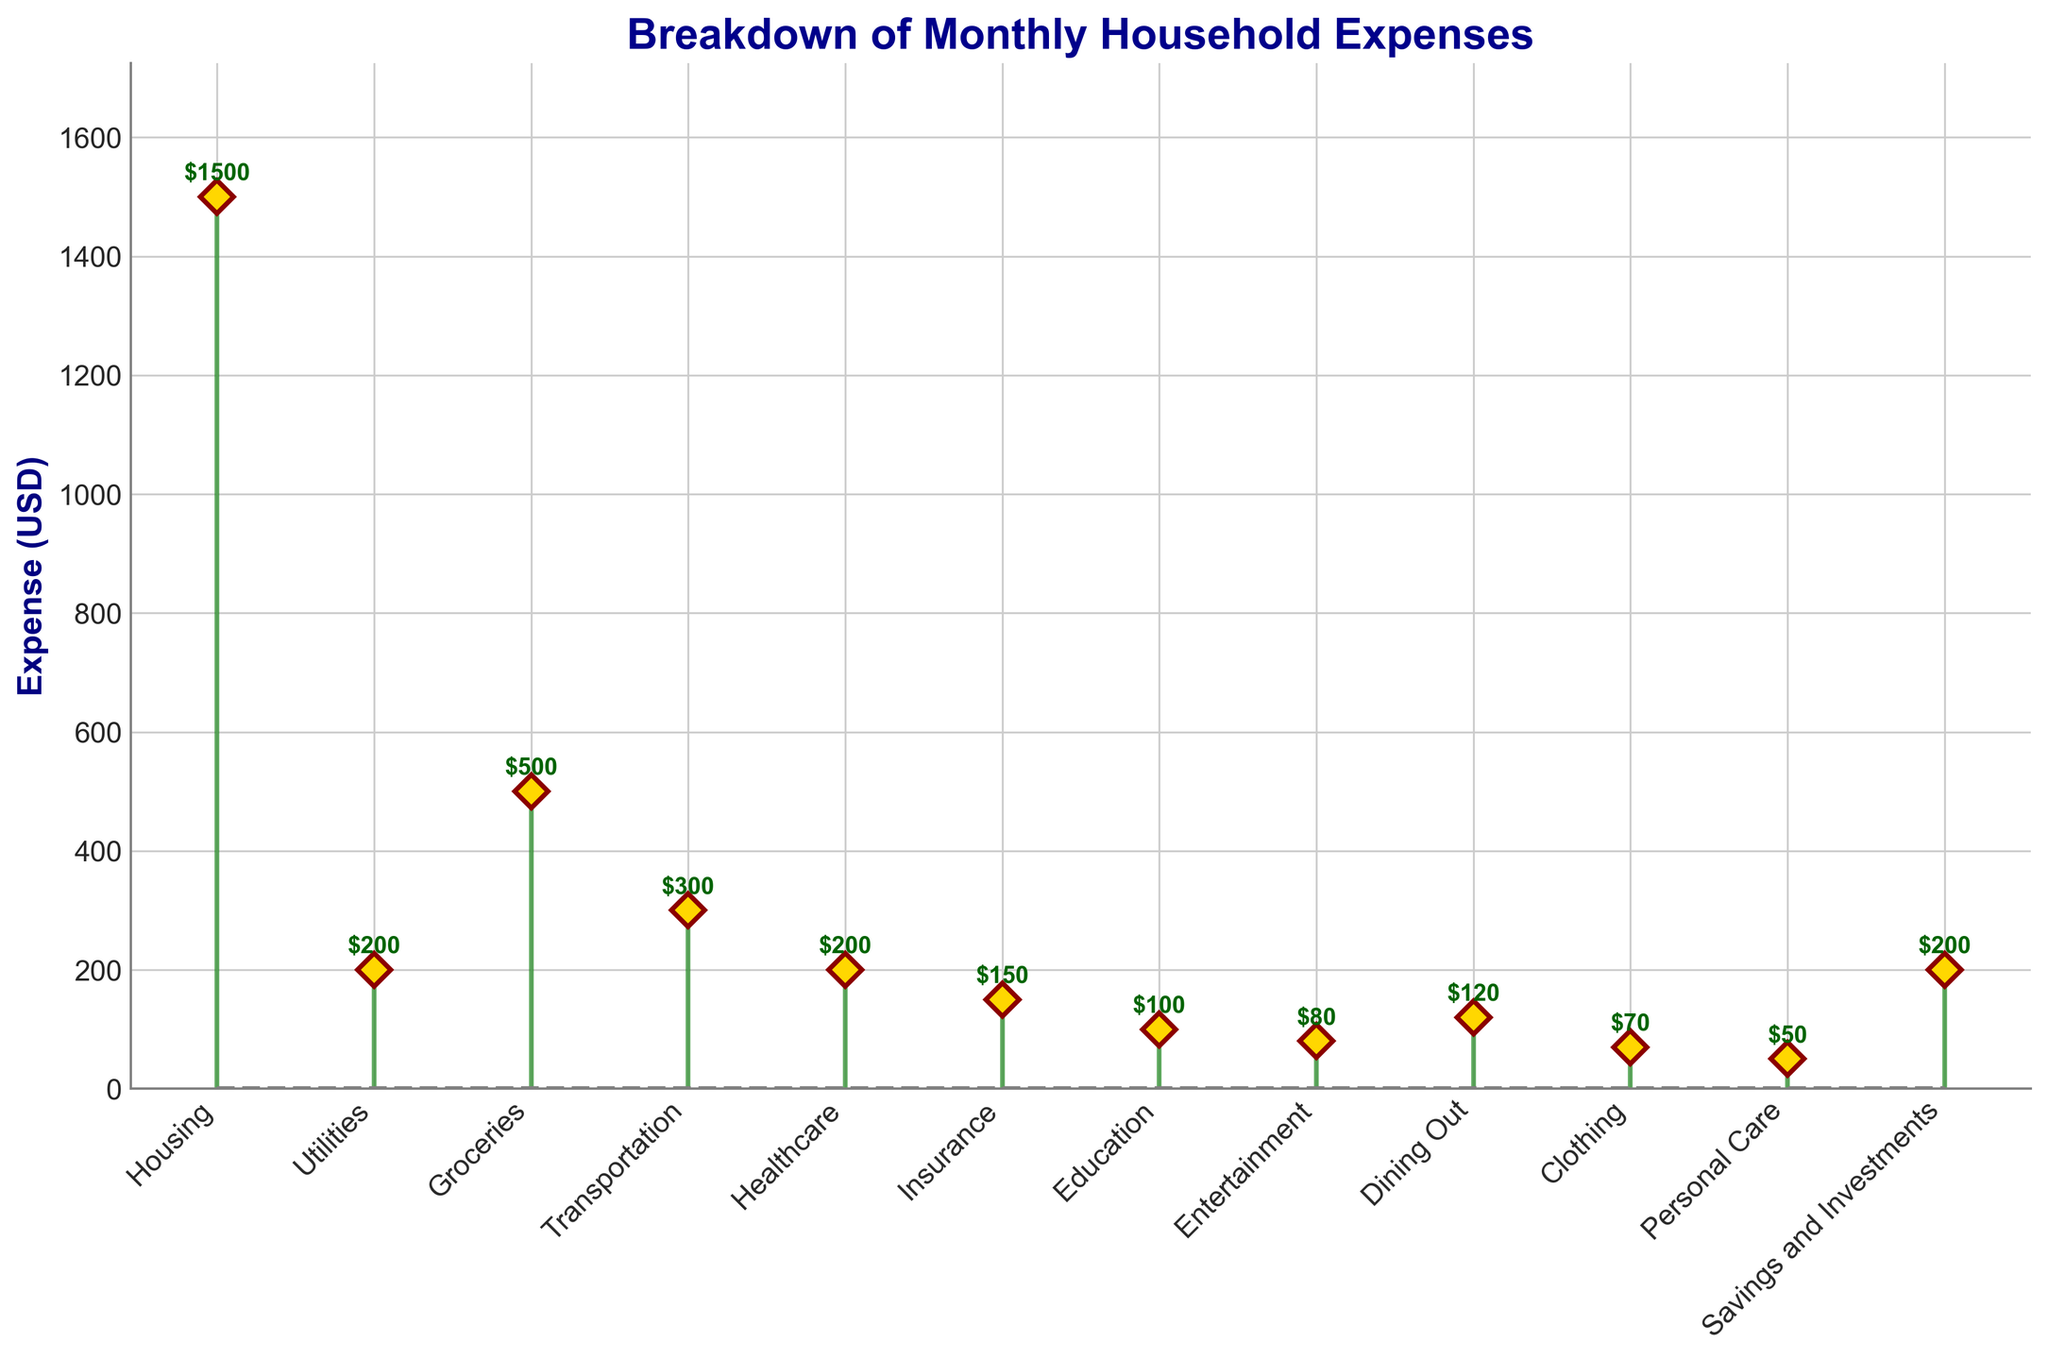What is the title of the plot? The title is usually found at the top of the plot, written in a larger font and often in bold. In this case, it is clear and easy to read.
Answer: Breakdown of Monthly Household Expenses What is the expense for Housing? Look for the "Housing" category on the x-axis and check the value explicitly labeled next to it.
Answer: $1500 How many categories have an expense of $200 or less? Identify and count the bars or markers with values of $200, $150, $100, $80, $70, and $50 accordingly. Here, those categories are Utilities, Healthcare, Insurance, Education, Entertainment, Clothing, and Personal Care.
Answer: 7 Which category has the lowest expense? Examine all the expenses noted on the markers to find the smallest value, which corresponds to the smallest label.
Answer: Personal Care How much more do Housing expenses exceed Groceries expenses? Find the amounts for Housing ($1500) and Groceries ($500). Subtract the Groceries expense from the Housing expense: $1500 - $500 = $1000.
Answer: $1000 What is the total expense for necessities (Housing, Utilities, Groceries, and Transportation)? Add the expenses of these categories: $1500 (Housing) + $200 (Utilities) + $500 (Groceries) + $300 (Transportation) = $2500.
Answer: $2500 Which two categories combined make up an expense equal to Healthcare? Look for two categories whose sum is $200. In this case, $150 (Insurance) + $50 (Personal Care) = $200.
Answer: Insurance and Personal Care What percentage of the total expenses does Groceries constitute? First, sum up all expenses: $1500 + $200 + $500 + $300 + $200 + $150 + $100 + $80 + $120 + $70 + $50 + $200 = $3470. Then, find the percentage of Groceries: ($500 / $3470) * 100 ≈ 14.4%.
Answer: 14.4% Do any categories have the same expense? Look for repeated values in the expenses. In this case, Utilities and Healthcare both have $200.
Answer: Yes, Utilities and Healthcare 